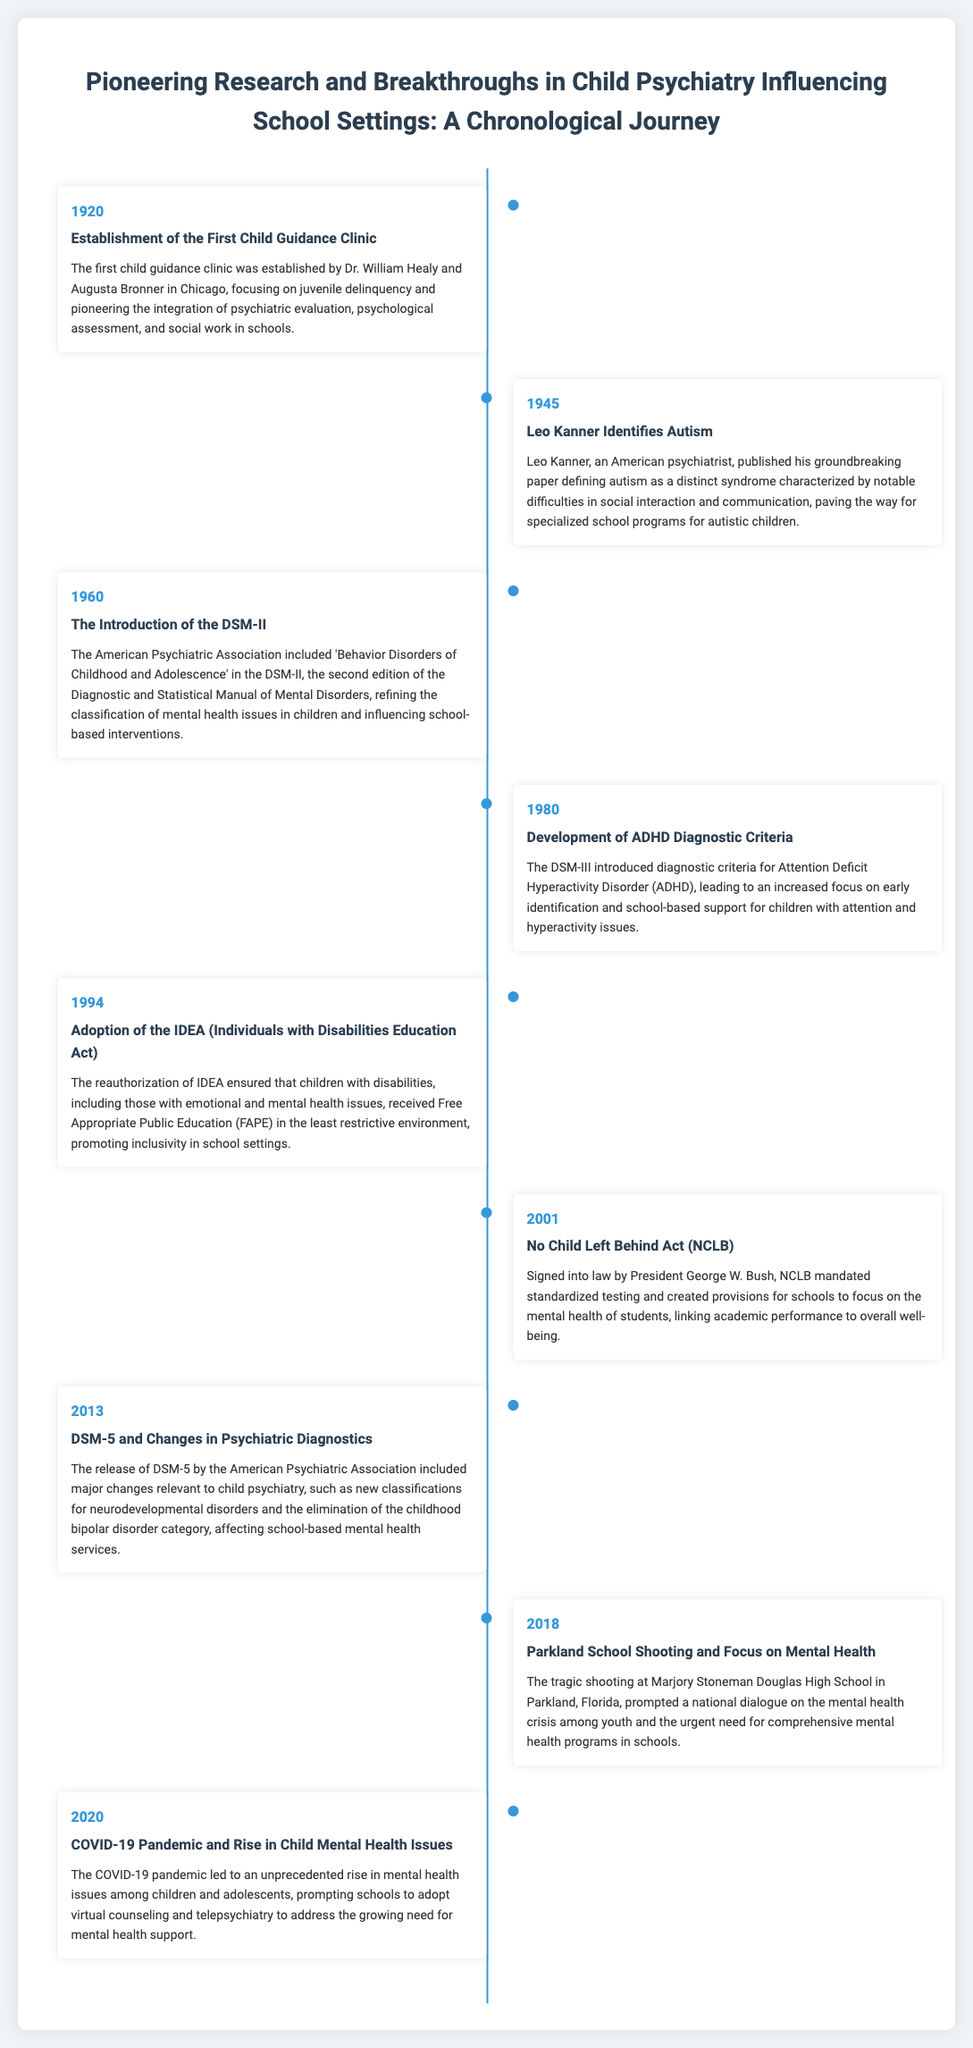What year was the first child guidance clinic established? The first child guidance clinic was established in Chicago in the year 1920 by Dr. William Healy and Augusta Bronner.
Answer: 1920 Who identified autism in 1945? Leo Kanner published his groundbreaking paper defining autism as a distinct syndrome in 1945.
Answer: Leo Kanner What major act was reauthorized in 1994? The Individuals with Disabilities Education Act (IDEA) was reauthorized in 1994.
Answer: IDEA What does NCLB stand for? NCLB refers to the No Child Left Behind Act, signed into law in 2001.
Answer: No Child Left Behind Act Which document made major changes to psychiatric diagnostics in 2013? The DSM-5 released by the American Psychiatric Association included significant changes in 2013.
Answer: DSM-5 In what year did the COVID-19 pandemic rise mental health issues among children? The COVID-19 pandemic led to a rise in child mental health issues in the year 2020.
Answer: 2020 What was a significant outcome of the Parkland school shooting in 2018? The shooting prompted a national dialogue on the mental health crisis among youth, emphasizing school mental health programs.
Answer: National dialogue on mental health How did the introduction of DSM-II in 1960 influence schools? DSM-II refined the classification of mental health issues in children, impacting school-based interventions.
Answer: Refined classification Which criteria were developed in 1980 that affected school support? The DSM-III introduced diagnostic criteria for Attention Deficit Hyperactivity Disorder (ADHD), emphasizing school support.
Answer: ADHD Diagnostic Criteria 